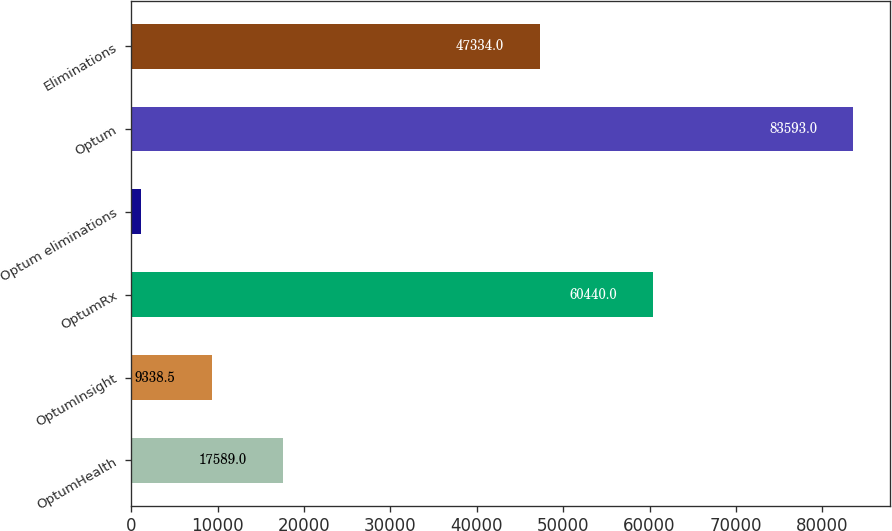Convert chart to OTSL. <chart><loc_0><loc_0><loc_500><loc_500><bar_chart><fcel>OptumHealth<fcel>OptumInsight<fcel>OptumRx<fcel>Optum eliminations<fcel>Optum<fcel>Eliminations<nl><fcel>17589<fcel>9338.5<fcel>60440<fcel>1088<fcel>83593<fcel>47334<nl></chart> 